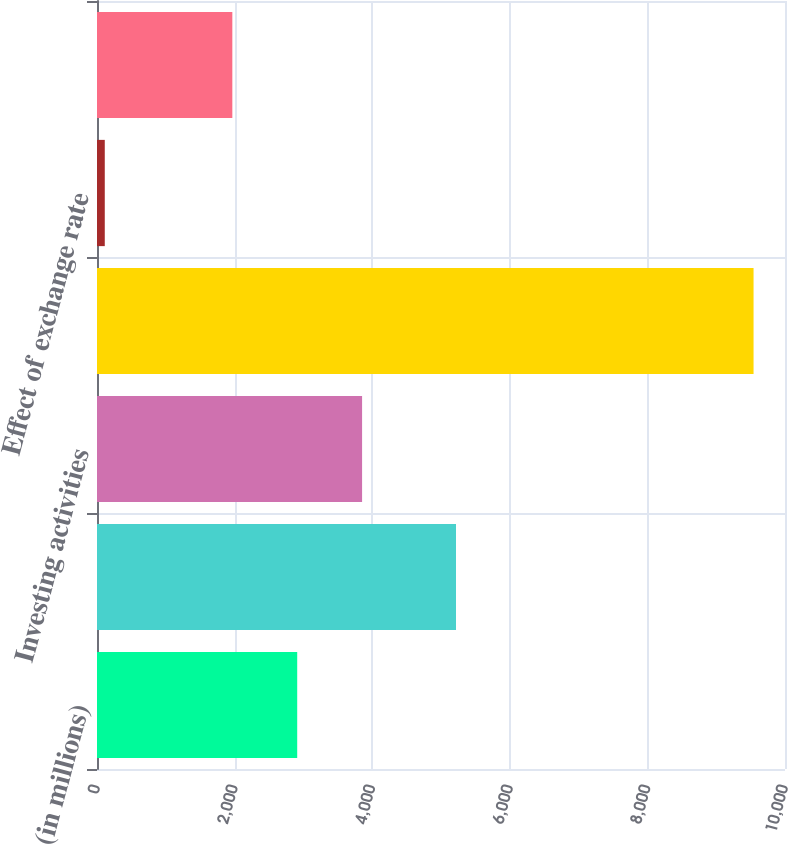<chart> <loc_0><loc_0><loc_500><loc_500><bar_chart><fcel>(in millions)<fcel>Operating activities<fcel>Investing activities<fcel>Financing activities<fcel>Effect of exchange rate<fcel>NET CHANGE IN CASH AND CASH<nl><fcel>2910<fcel>5218<fcel>3853<fcel>9543<fcel>113<fcel>1967<nl></chart> 